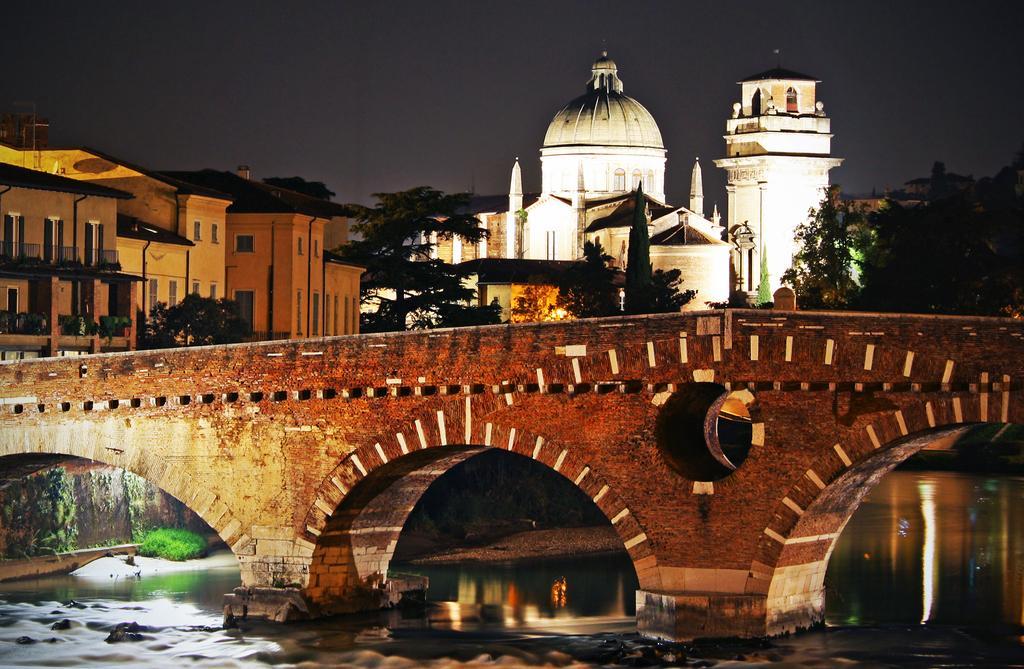In one or two sentences, can you explain what this image depicts? In the center of the image there is a bridge. At the bottom we can see water. In the background there are trees, buildings and sky. 